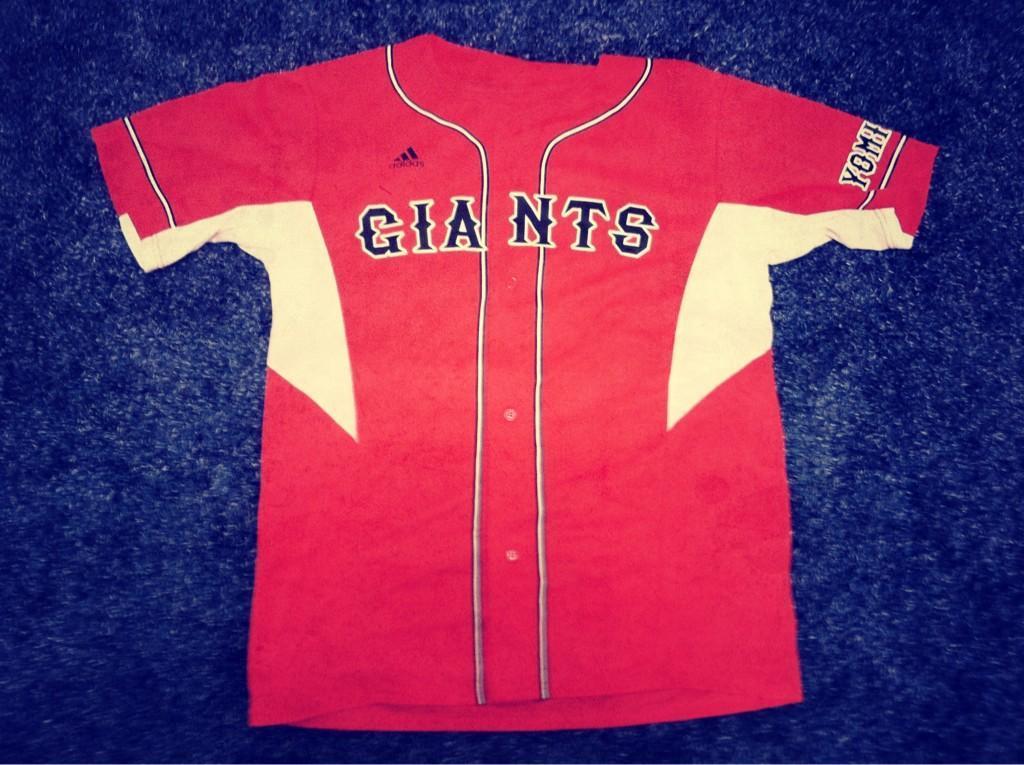Which apparel company sponsors the giants?
Offer a terse response. Adidas. What is the first letter of the word on the sleeve?
Your answer should be very brief. Y. 